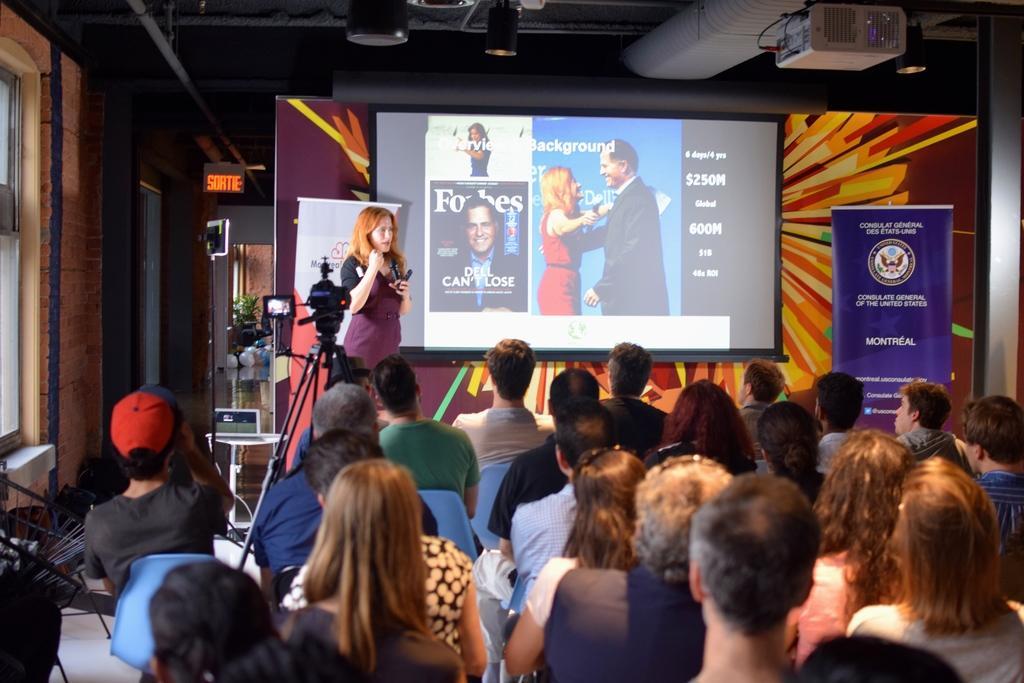Describe this image in one or two sentences. At the bottom of the image there are many people sitting. In front of them there is a stand with a camera and a lady. Behind the lady there on the wall there is a screen. Beside the screen there is a banner with text and logo. At the top of the image there is a ceiling with lights and a projector. On the left side of the image there is a wall with windows. And also there are some other things in the image. 